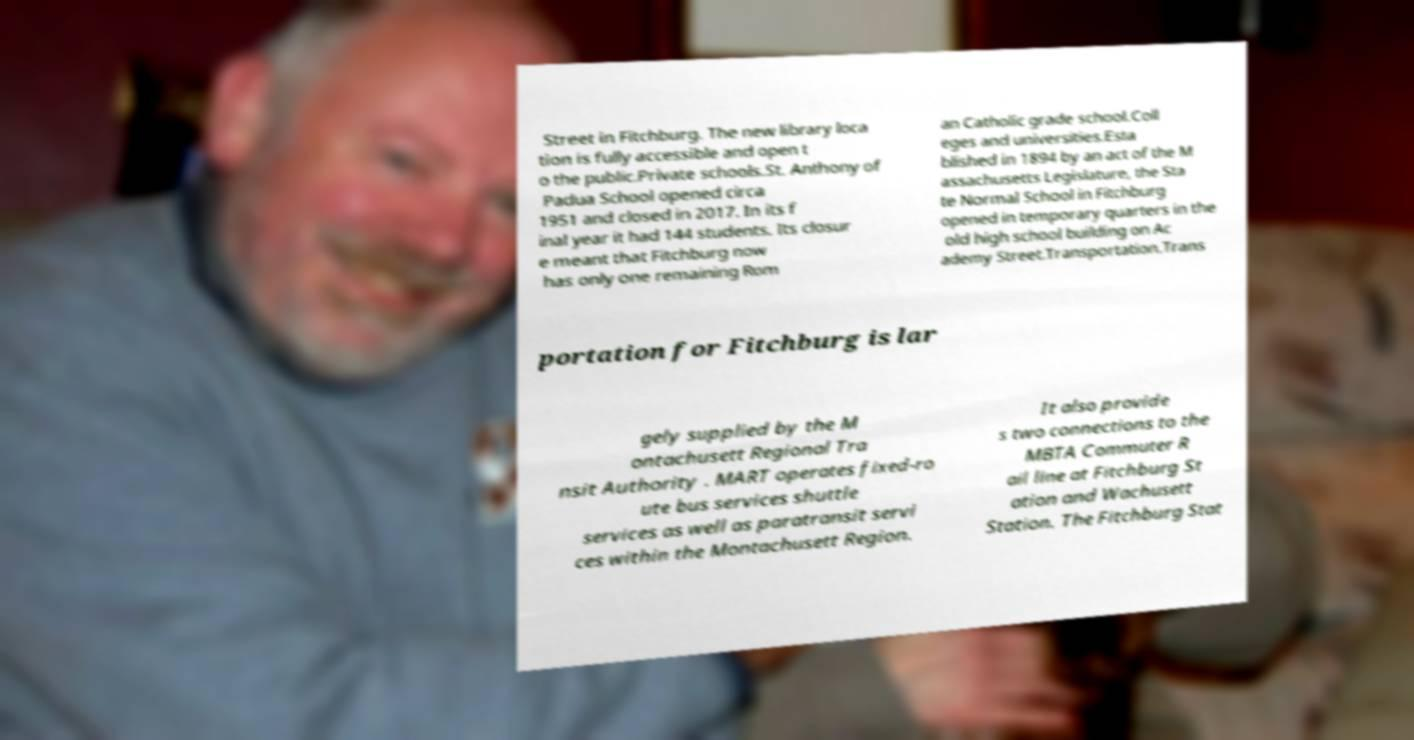There's text embedded in this image that I need extracted. Can you transcribe it verbatim? Street in Fitchburg. The new library loca tion is fully accessible and open t o the public.Private schools.St. Anthony of Padua School opened circa 1951 and closed in 2017. In its f inal year it had 144 students. Its closur e meant that Fitchburg now has only one remaining Rom an Catholic grade school.Coll eges and universities.Esta blished in 1894 by an act of the M assachusetts Legislature, the Sta te Normal School in Fitchburg opened in temporary quarters in the old high school building on Ac ademy Street.Transportation.Trans portation for Fitchburg is lar gely supplied by the M ontachusett Regional Tra nsit Authority . MART operates fixed-ro ute bus services shuttle services as well as paratransit servi ces within the Montachusett Region. It also provide s two connections to the MBTA Commuter R ail line at Fitchburg St ation and Wachusett Station. The Fitchburg Stat 